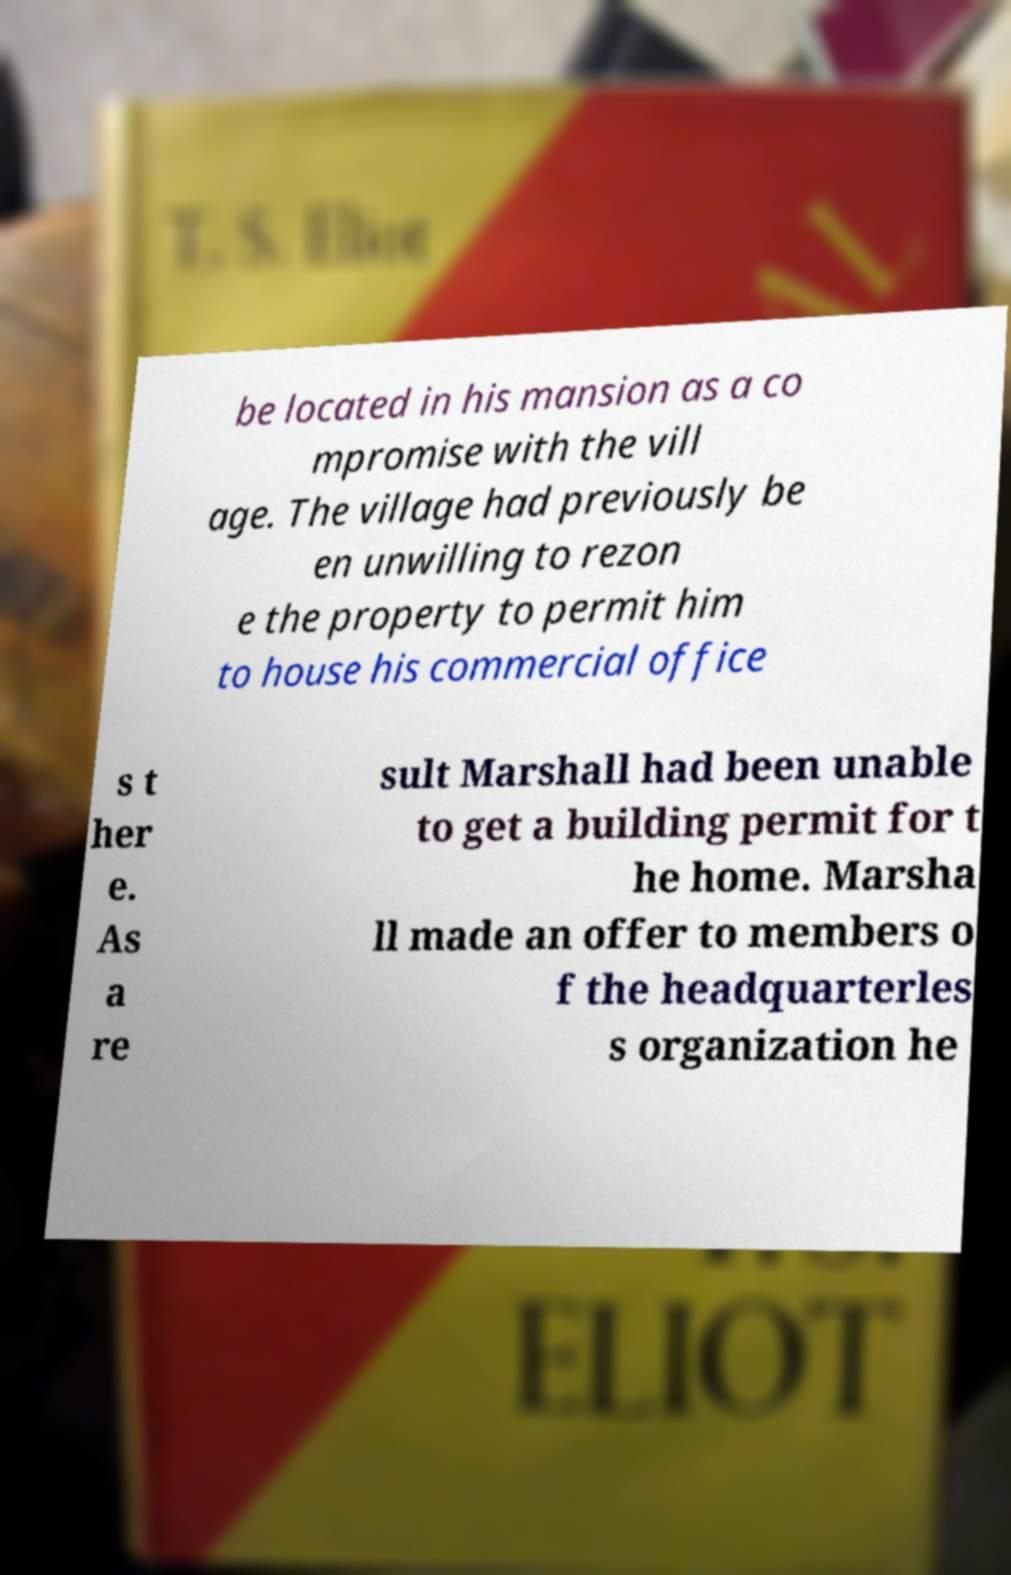Please read and relay the text visible in this image. What does it say? be located in his mansion as a co mpromise with the vill age. The village had previously be en unwilling to rezon e the property to permit him to house his commercial office s t her e. As a re sult Marshall had been unable to get a building permit for t he home. Marsha ll made an offer to members o f the headquarterles s organization he 